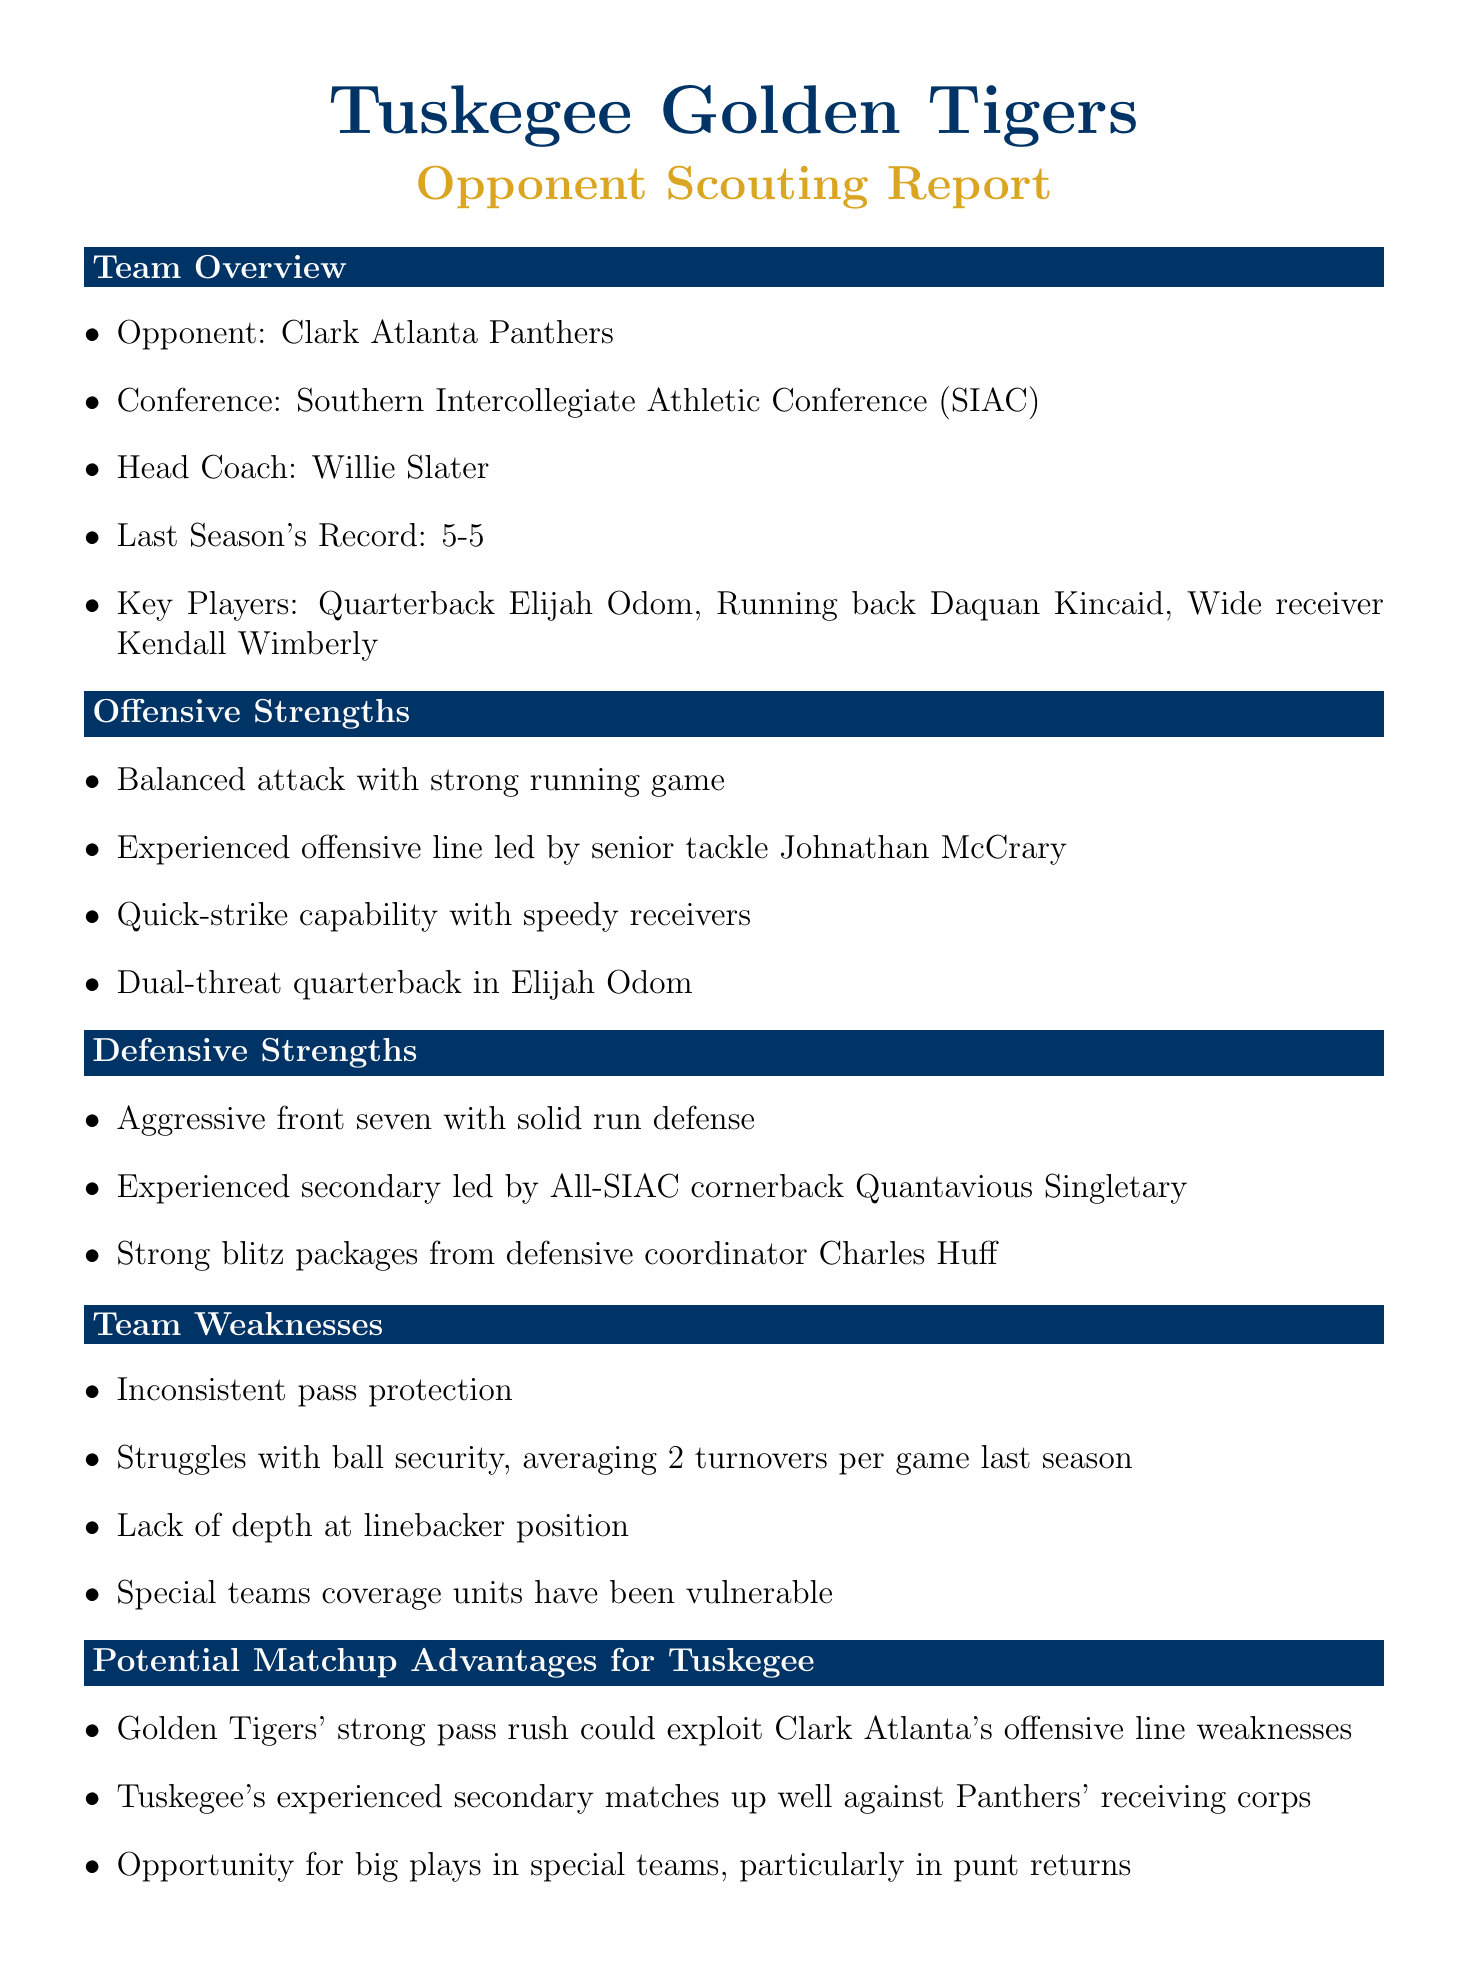What is the name of the opponent? The document states that the opponent is the Clark Atlanta Panthers.
Answer: Clark Atlanta Panthers Who is the head coach of the opposing team? The report identifies Willie Slater as the head coach of the Clark Atlanta Panthers.
Answer: Willie Slater What was Clark Atlanta's record last season? The document notes that Clark Atlanta had a record of 5-5 last season.
Answer: 5-5 Who is listed as a key player for Clark Atlanta? The report highlights quarterback Elijah Odom as a key player for Clark Atlanta.
Answer: Elijah Odom What is a weakness of the Clark Atlanta Panthers? The document mentions inconsistent pass protection as a weakness for Clark Atlanta.
Answer: Inconsistent pass protection What advantage does Tuskegee have regarding special teams? The report suggests an opportunity for big plays in special teams, specifically in punt returns.
Answer: Big plays in special teams What is Clark Atlanta's third-down conversion rate? According to the report, Clark Atlanta's third-down conversion rate is 38%.
Answer: 38% If Daquan Kincaid is questionable, what is the status of Jalen Thomas? The document states that Jalen Thomas is out due to a concussion.
Answer: Out What is the historical record between Tuskegee and Clark Atlanta? The report indicates that Tuskegee leads with a historical record of 62-29-4 against Clark Atlanta.
Answer: 62-29-4 